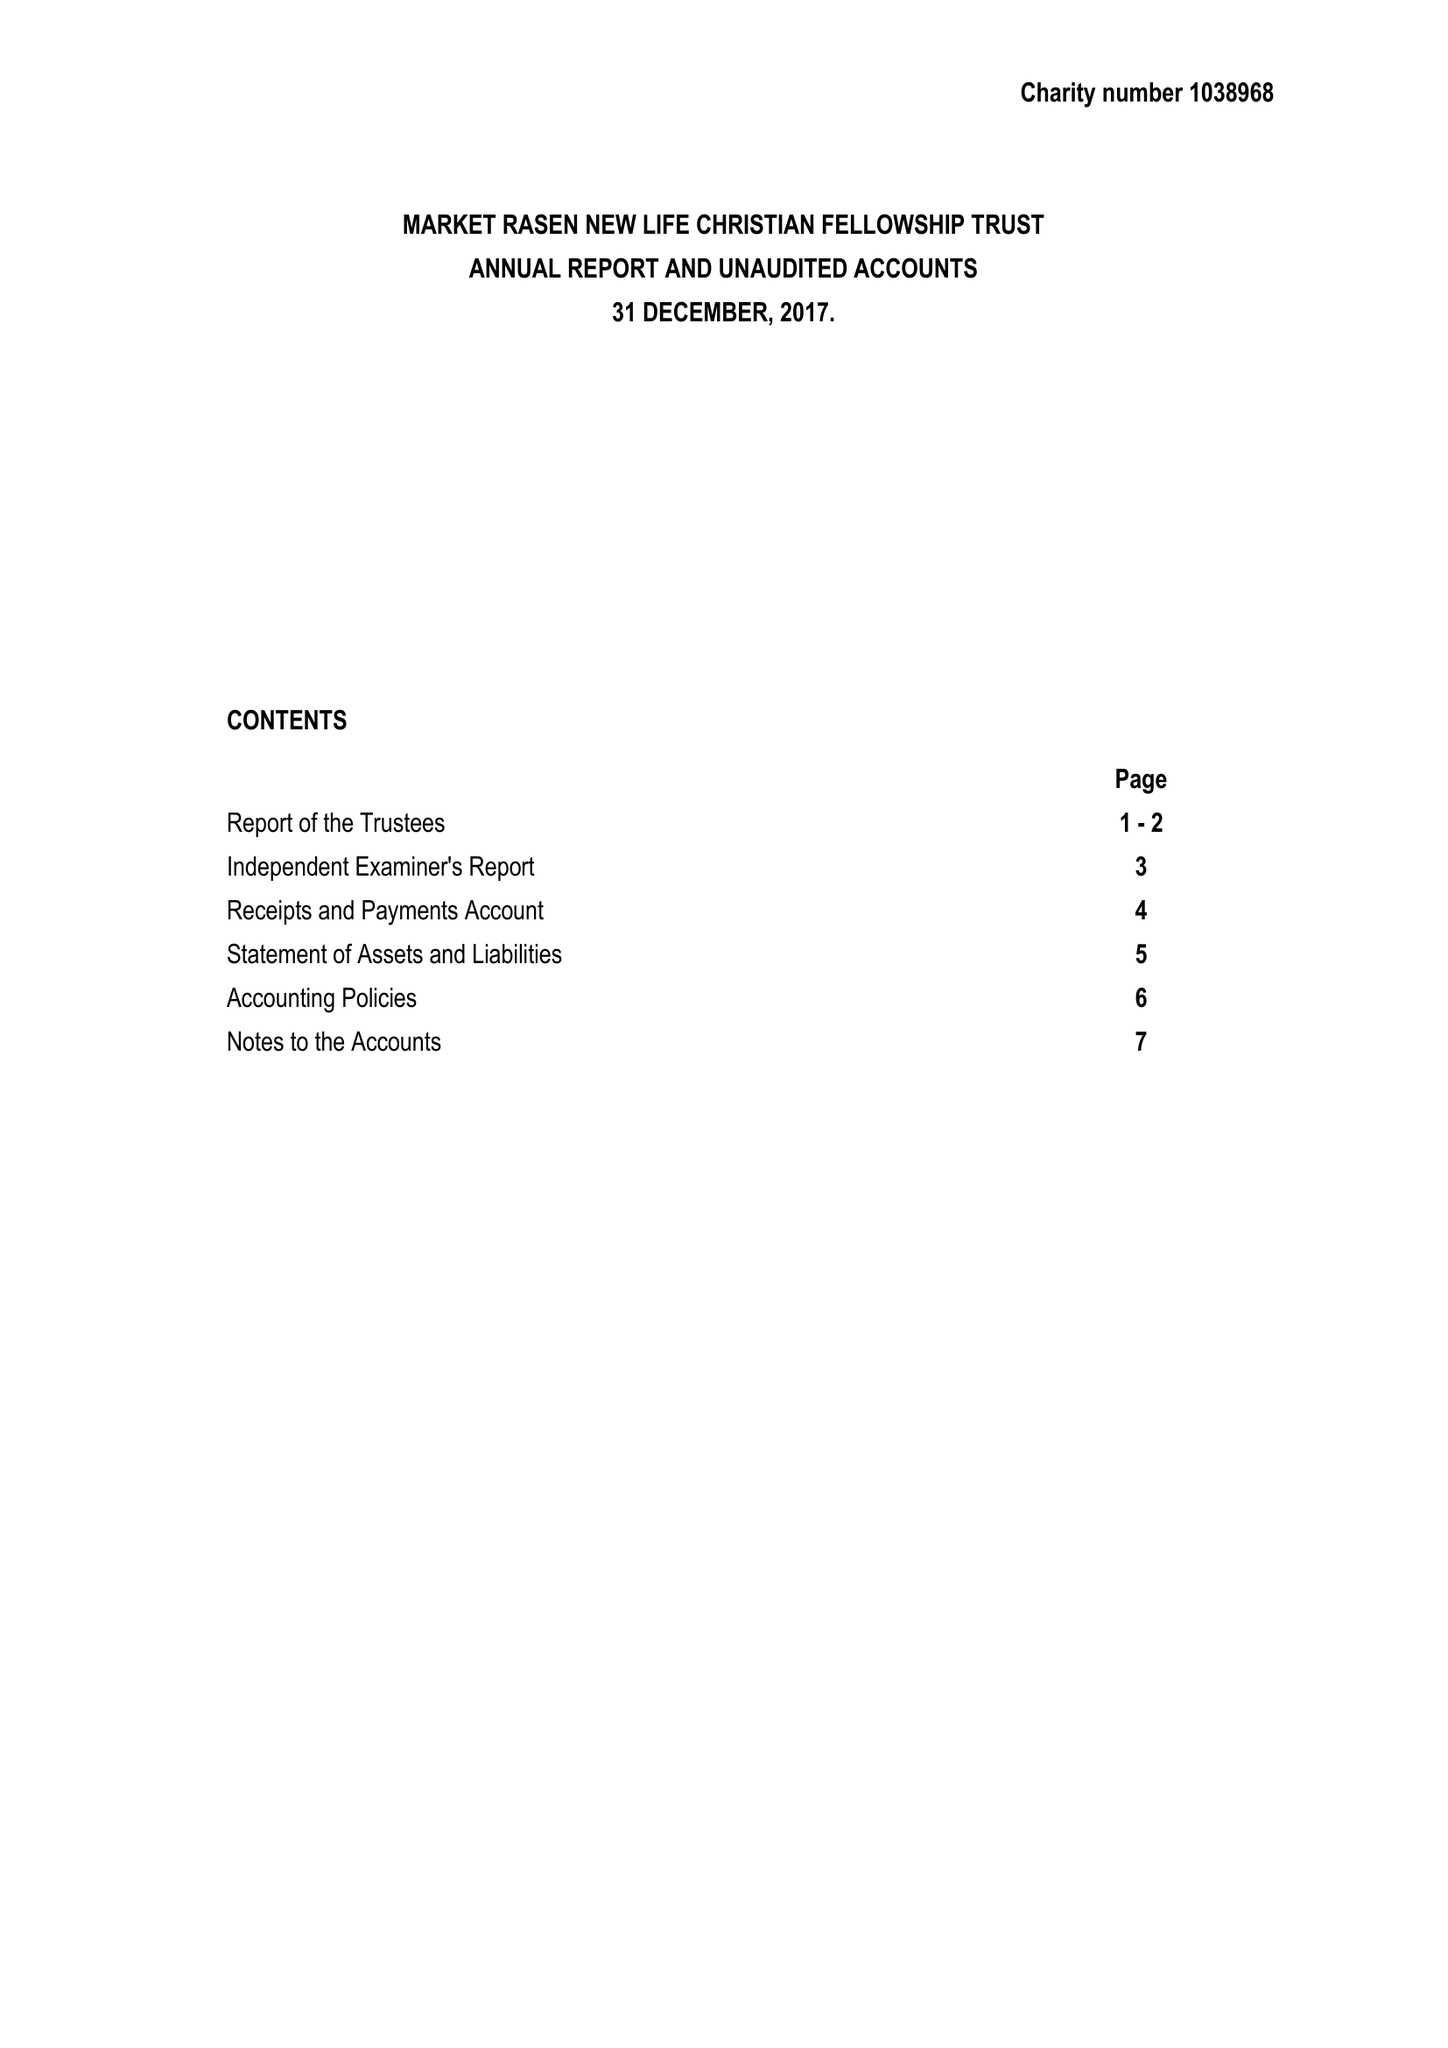What is the value for the address__street_line?
Answer the question using a single word or phrase. SERPENTINE STREET 